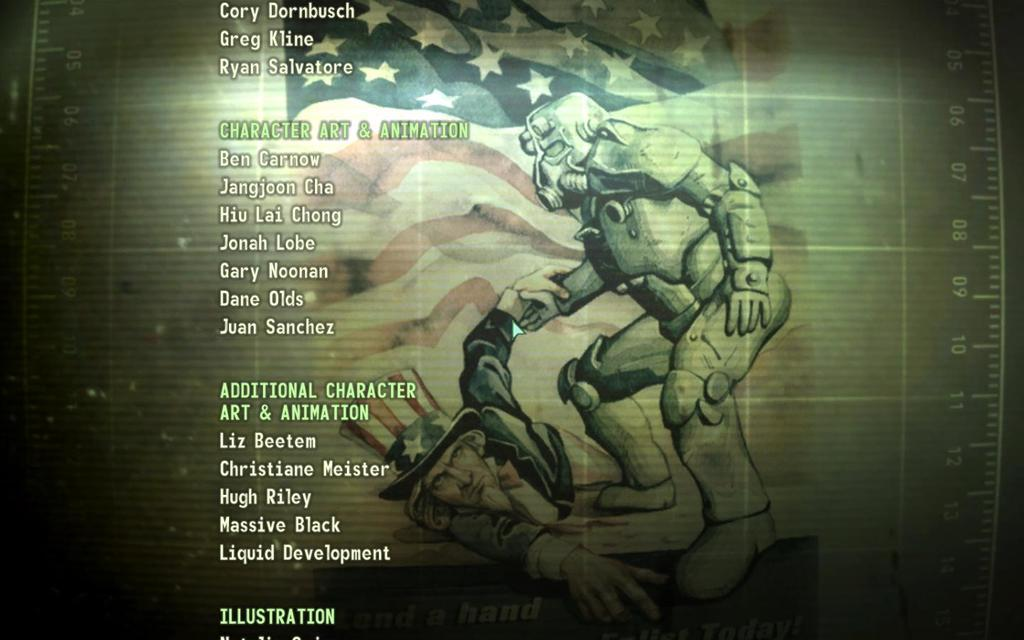<image>
Create a compact narrative representing the image presented. The credits scren of Fallout video game with Uncle Sam laying on the ground and the credits for Additional Character Art and Animation displayed. 